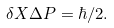Convert formula to latex. <formula><loc_0><loc_0><loc_500><loc_500>\delta X \Delta P = \hbar { / } 2 .</formula> 